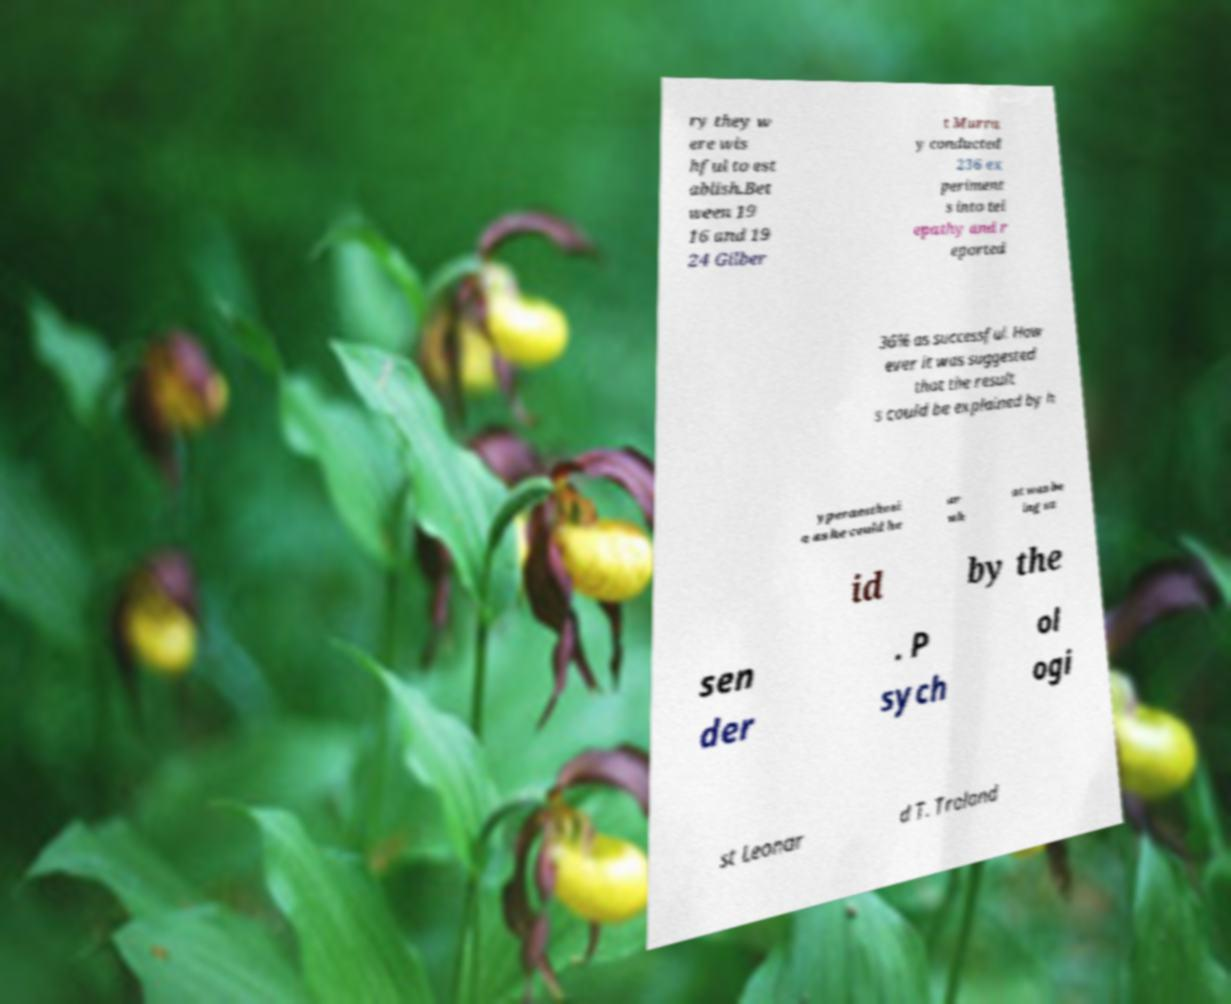I need the written content from this picture converted into text. Can you do that? ry they w ere wis hful to est ablish.Bet ween 19 16 and 19 24 Gilber t Murra y conducted 236 ex periment s into tel epathy and r eported 36% as successful. How ever it was suggested that the result s could be explained by h yperaesthesi a as he could he ar wh at was be ing sa id by the sen der . P sych ol ogi st Leonar d T. Troland 